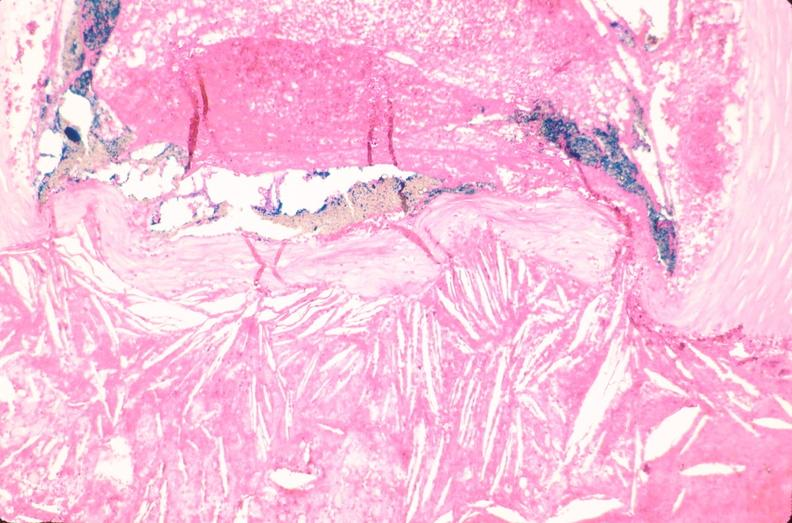what is present?
Answer the question using a single word or phrase. Vasculature 